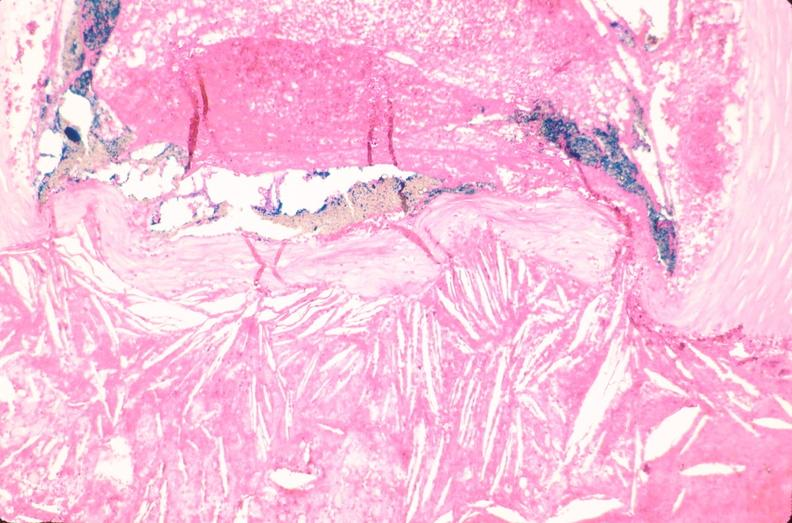what is present?
Answer the question using a single word or phrase. Vasculature 